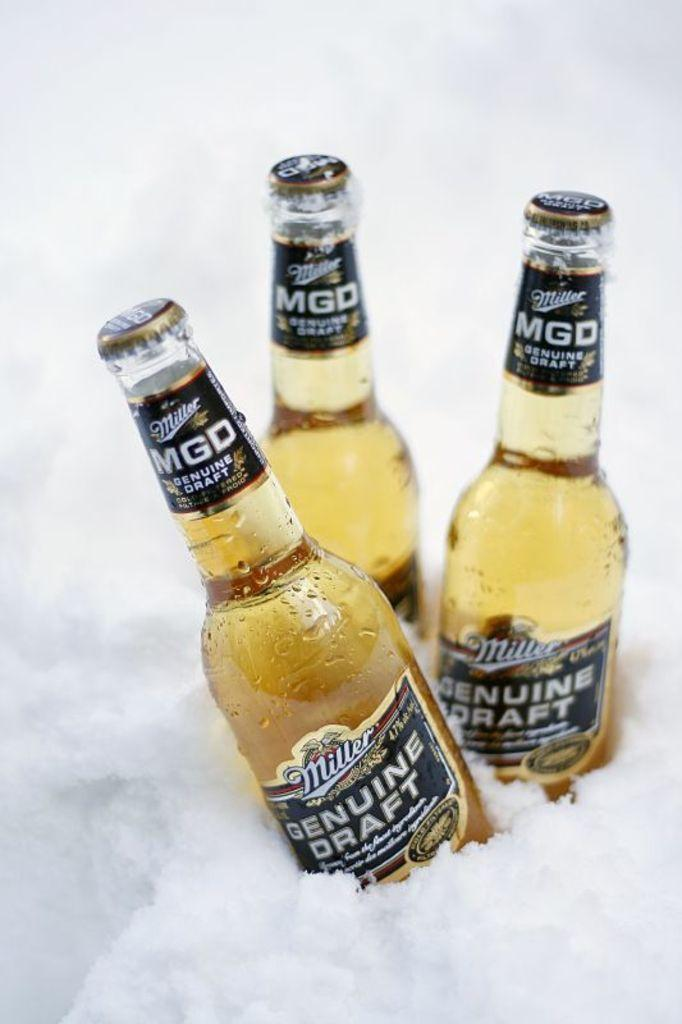What type of bottles are visible in the image? There are wine bottles in the image. Where are the wine bottles located? The wine bottles are in the snow. What is the purpose of the milk in the image? There is no milk present in the image, so it cannot serve any purpose. 